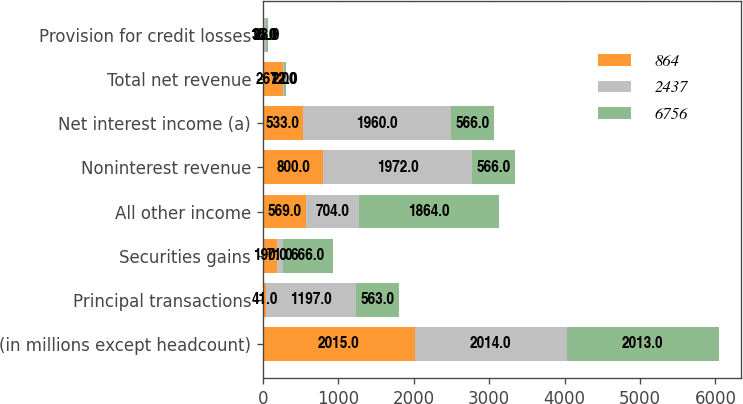Convert chart. <chart><loc_0><loc_0><loc_500><loc_500><stacked_bar_chart><ecel><fcel>(in millions except headcount)<fcel>Principal transactions<fcel>Securities gains<fcel>All other income<fcel>Noninterest revenue<fcel>Net interest income (a)<fcel>Total net revenue<fcel>Provision for credit losses<nl><fcel>864<fcel>2015<fcel>41<fcel>190<fcel>569<fcel>800<fcel>533<fcel>267<fcel>10<nl><fcel>2437<fcel>2014<fcel>1197<fcel>71<fcel>704<fcel>1972<fcel>1960<fcel>12<fcel>35<nl><fcel>6756<fcel>2013<fcel>563<fcel>666<fcel>1864<fcel>566<fcel>566<fcel>22<fcel>28<nl></chart> 